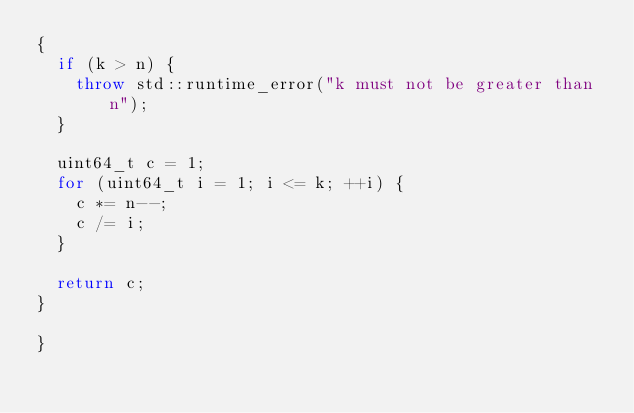Convert code to text. <code><loc_0><loc_0><loc_500><loc_500><_C++_>{
  if (k > n) {
    throw std::runtime_error("k must not be greater than n");
  }

  uint64_t c = 1;
  for (uint64_t i = 1; i <= k; ++i) {
    c *= n--;
    c /= i;
  }

  return c;
}

}
</code> 